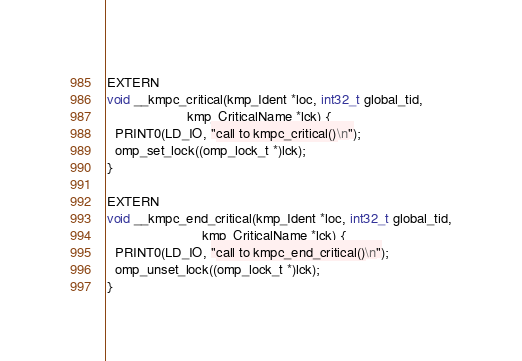<code> <loc_0><loc_0><loc_500><loc_500><_Cuda_>
EXTERN
void __kmpc_critical(kmp_Ident *loc, int32_t global_tid,
                     kmp_CriticalName *lck) {
  PRINT0(LD_IO, "call to kmpc_critical()\n");
  omp_set_lock((omp_lock_t *)lck);
}

EXTERN
void __kmpc_end_critical(kmp_Ident *loc, int32_t global_tid,
                         kmp_CriticalName *lck) {
  PRINT0(LD_IO, "call to kmpc_end_critical()\n");
  omp_unset_lock((omp_lock_t *)lck);
}
</code> 